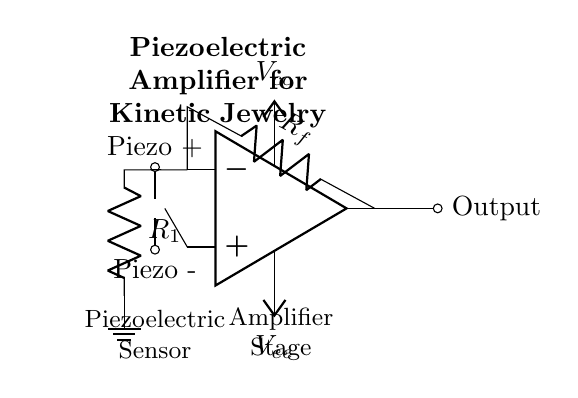What is the type of sensor used in this circuit? The circuit diagram shows a piezoelectric sensor, which is indicated by the symbol labeled "Piezoelectric" on the left side of the circuit.
Answer: Piezoelectric What are the resistor values shown in the amplifier stage? The diagram displays two resistors, R_f and R_1, but does not specify their numerical values. This means additional information would be required to give specific values.
Answer: Not specified What is the function of the op-amp in this circuit? The op-amp is configured as an amplifier to increase the voltage output generated by the piezoelectric sensor when it detects vibrations, facilitating further signal processing or use.
Answer: Amplification How many power supply connections are present in the circuit? There are two power supply connections, labeled V_cc and V_ee, which provide the necessary power supply voltages for the operational amplifier to function correctly.
Answer: Two What is the output type of this circuit? The output, labeled "Output," shown on the right side of the op-amp indicates it provides a single output signal corresponding to the amplified vibrations detected by the sensor.
Answer: Single output What is the purpose of the feedback resistor R_f in the circuit? R_f provides feedback from the output of the op-amp back to its inverting input, allowing for control over the gain of the amplification, which is crucial for achieving the desired response from the piezoelectric sensor.
Answer: Gain control 